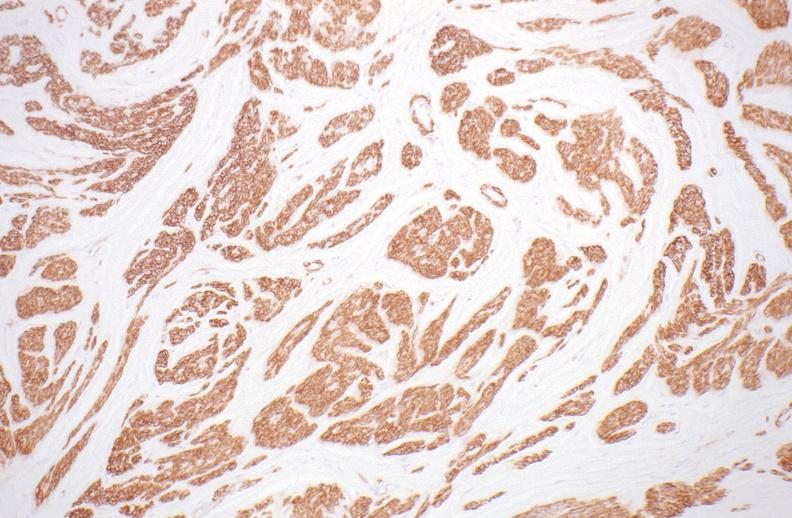do atherosclerosis stain?
Answer the question using a single word or phrase. No 